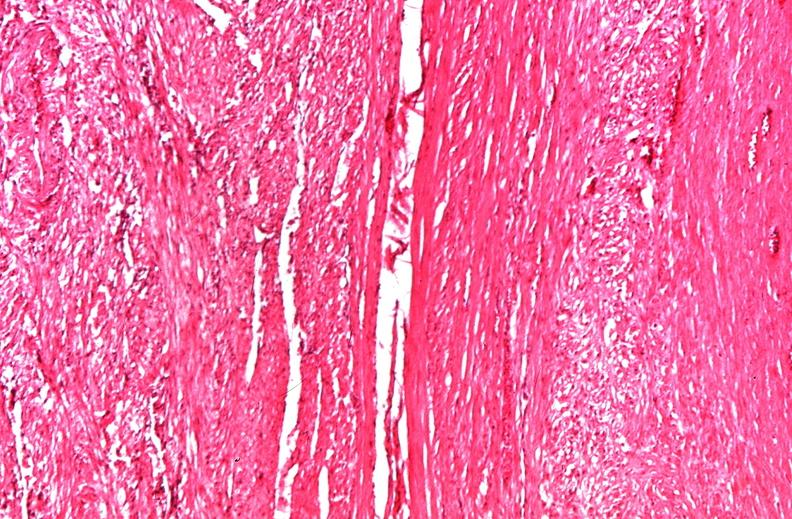does this image show uterus, leiomyomas?
Answer the question using a single word or phrase. Yes 